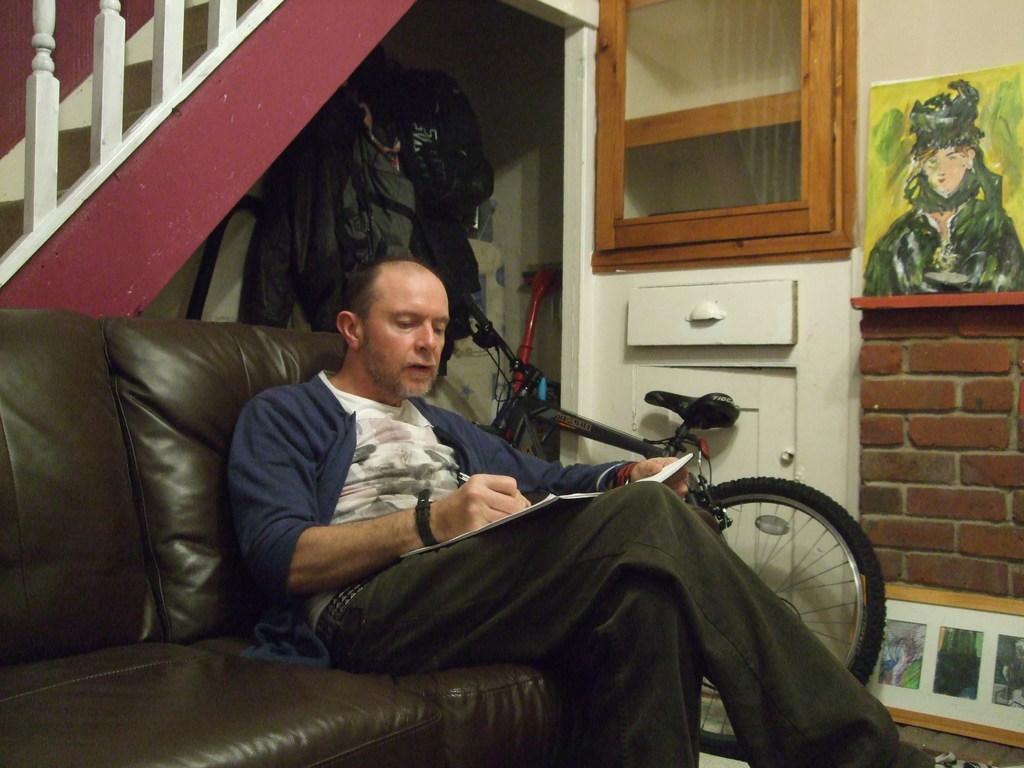In one or two sentences, can you explain what this image depicts? Man sitting on the sofa near the bicycle and on the wall there is painting and the shelf. 